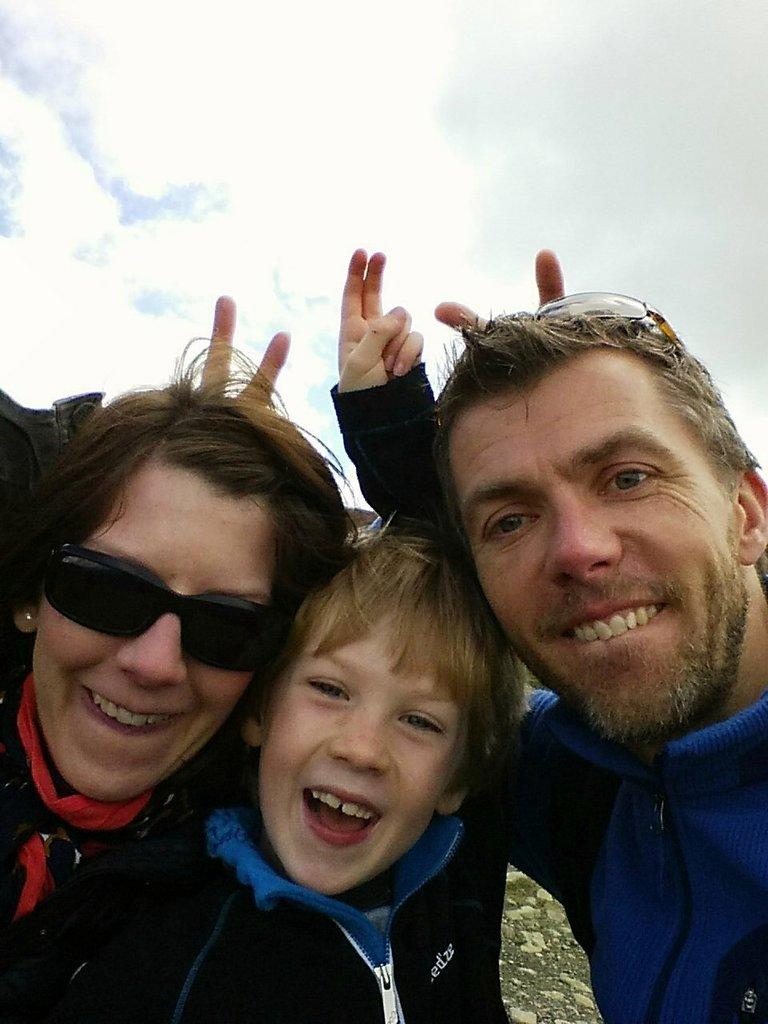How many people are in the foreground of the image? There are three people in the foreground of the image: a woman, a man, and a boy. What are the people in the foreground doing? The woman, man, and boy are raising fingers behind their heads. What can be seen in the background of the image? The sky and clouds can be seen in the background of the image. How many bikes are parked next to the people in the image? There are no bikes present in the image. What type of books are the people reading in the image? There are no books present in the image. 